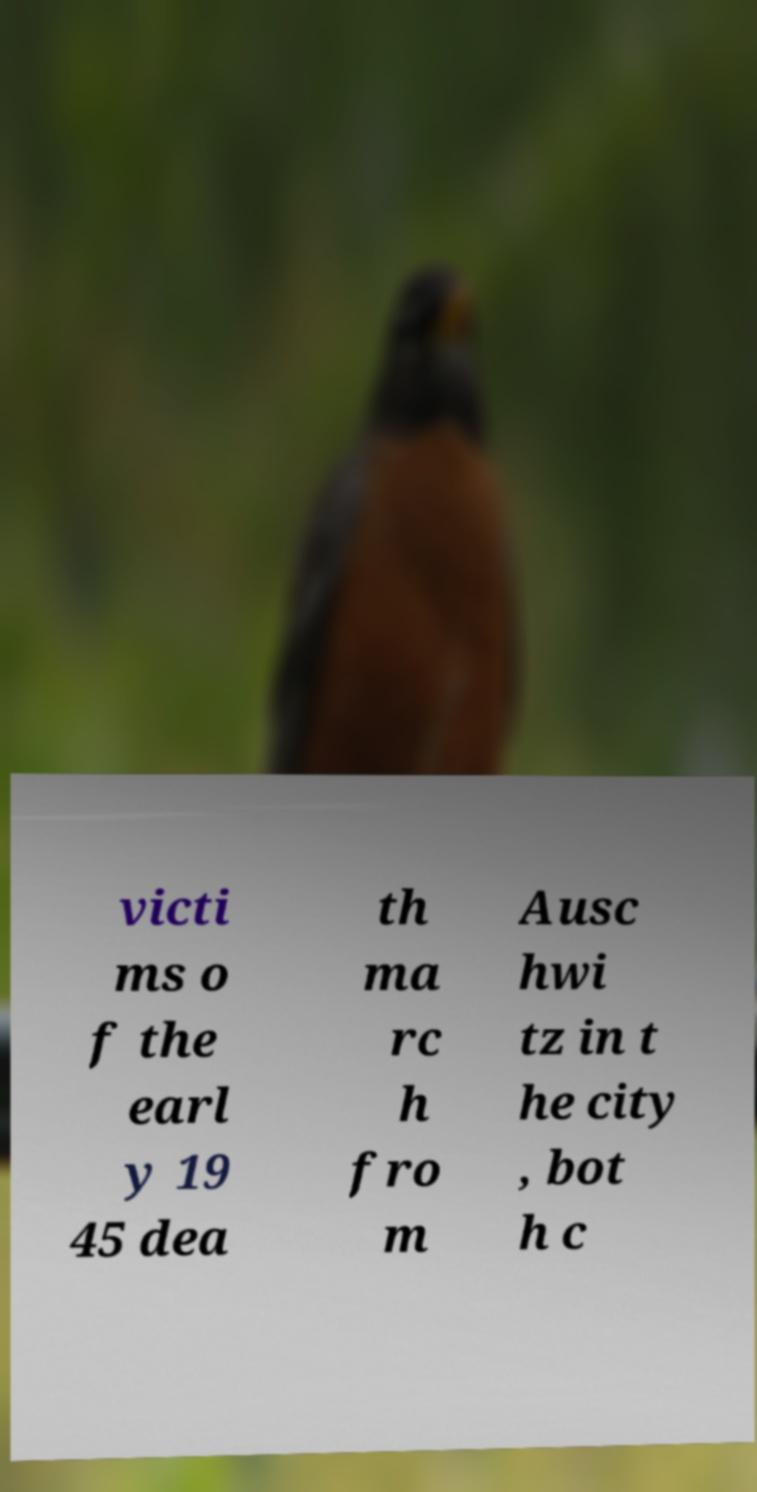Please identify and transcribe the text found in this image. victi ms o f the earl y 19 45 dea th ma rc h fro m Ausc hwi tz in t he city , bot h c 